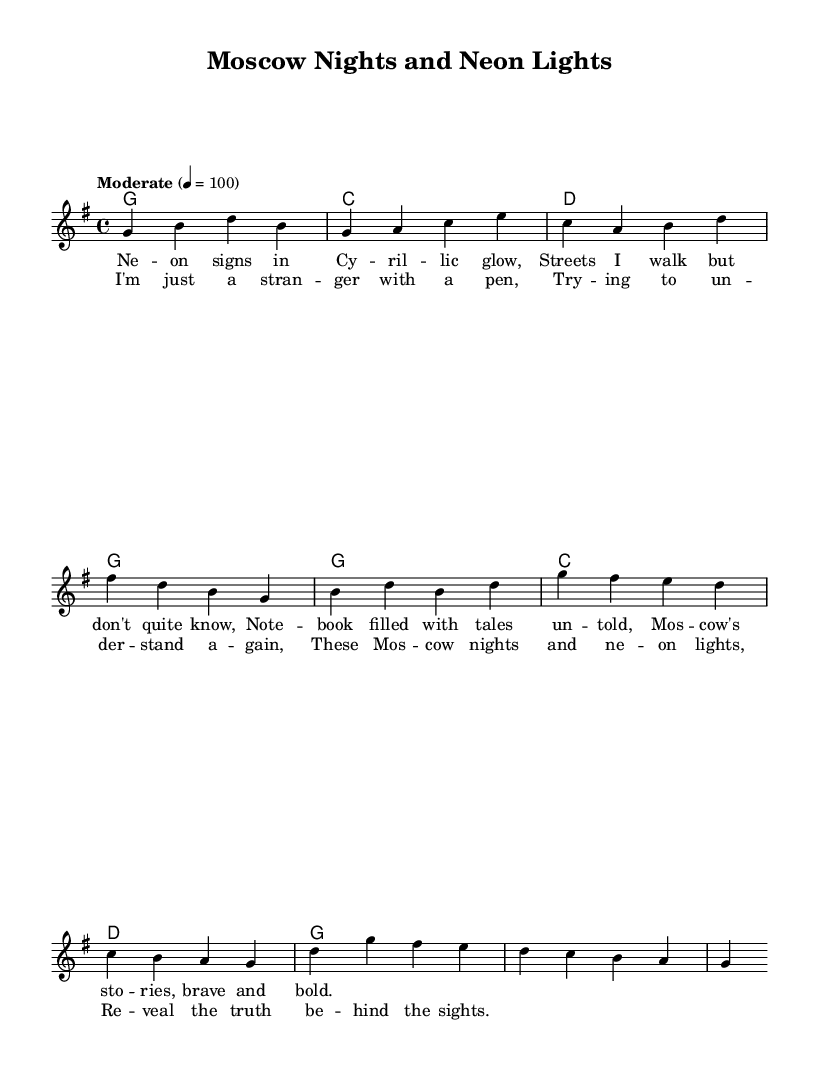What is the key signature of this music? The key signature is G major, which has one sharp (F#). This can be determined by examining the key signature shown at the beginning of the score.
Answer: G major What is the time signature of the piece? The time signature is 4/4, which is indicated prominently in the sheet music. It tells you that there are four beats in each measure.
Answer: 4/4 What is the tempo marking? The tempo marking states "Moderate" with a speed of 4 = 100, meaning there are 100 beats per minute. The tempo is clearly indicated at the top of the score.
Answer: Moderate 4 = 100 How many measures are there in the verse section? By counting the measures notated in the melody line and harmonies, there are four measures in the verse section, as indicated by the musical notation.
Answer: 4 What musical genre does this piece belong to? This piece is categorized as Country Rock, a genre that combines elements of country music with rock. This can be inferred from the overall style, rhythm, and thematic content.
Answer: Country Rock What is the first lyric line of the chorus? The first lyric line of the chorus is "I'm just a stranger with a pen," which can be found in the lyrics section aligned with the melody in the score.
Answer: I'm just a stranger with a pen What chords are used in the chorus section? The chords used in the chorus section are G, C, and D, which can be directly observed from the chord symbols above the melody in that section.
Answer: G, C, D 